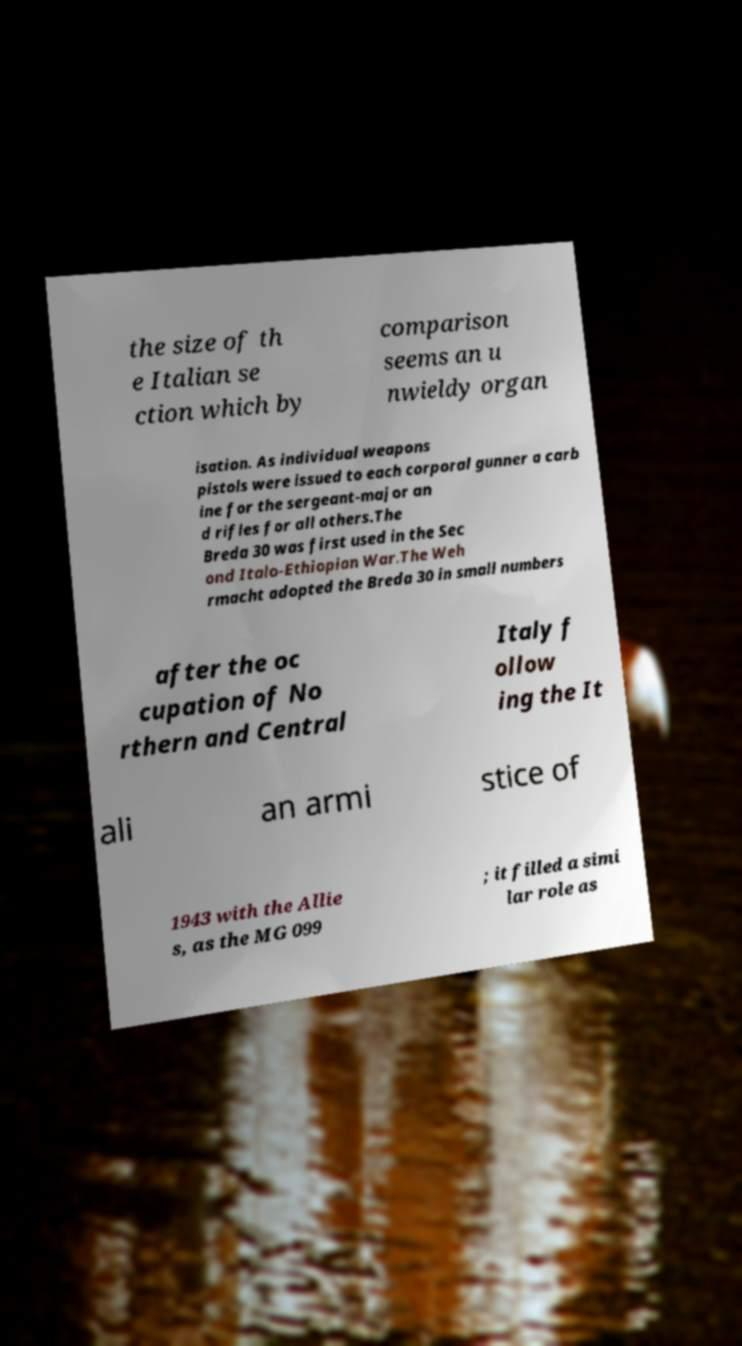What messages or text are displayed in this image? I need them in a readable, typed format. the size of th e Italian se ction which by comparison seems an u nwieldy organ isation. As individual weapons pistols were issued to each corporal gunner a carb ine for the sergeant-major an d rifles for all others.The Breda 30 was first used in the Sec ond Italo-Ethiopian War.The Weh rmacht adopted the Breda 30 in small numbers after the oc cupation of No rthern and Central Italy f ollow ing the It ali an armi stice of 1943 with the Allie s, as the MG 099 ; it filled a simi lar role as 